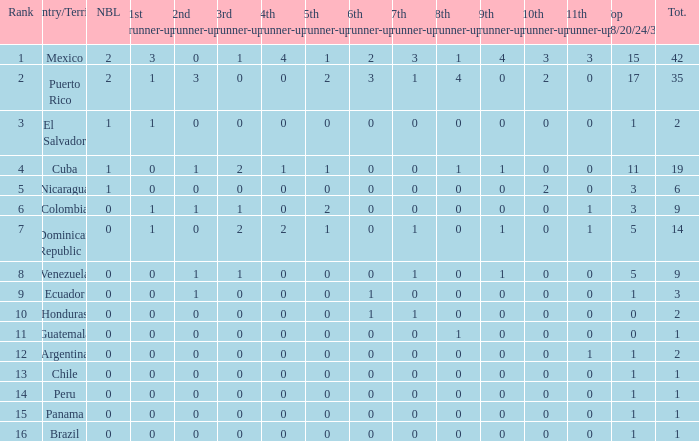What is the 3rd runner-up of the country with more than 0 9th runner-up, an 11th runner-up of 0, and the 1st runner-up greater than 0? None. Write the full table. {'header': ['Rank', 'Country/Territory', 'NBL', '1st runner-up', '2nd runner-up', '3rd runner-up', '4th runner-up', '5th runner-up', '6th runner-up', '7th runner-up', '8th runner-up', '9th runner-up', '10th runner-up', '11th runner-up', 'Top 18/20/24/30', 'Tot.'], 'rows': [['1', 'Mexico', '2', '3', '0', '1', '4', '1', '2', '3', '1', '4', '3', '3', '15', '42'], ['2', 'Puerto Rico', '2', '1', '3', '0', '0', '2', '3', '1', '4', '0', '2', '0', '17', '35'], ['3', 'El Salvador', '1', '1', '0', '0', '0', '0', '0', '0', '0', '0', '0', '0', '1', '2'], ['4', 'Cuba', '1', '0', '1', '2', '1', '1', '0', '0', '1', '1', '0', '0', '11', '19'], ['5', 'Nicaragua', '1', '0', '0', '0', '0', '0', '0', '0', '0', '0', '2', '0', '3', '6'], ['6', 'Colombia', '0', '1', '1', '1', '0', '2', '0', '0', '0', '0', '0', '1', '3', '9'], ['7', 'Dominican Republic', '0', '1', '0', '2', '2', '1', '0', '1', '0', '1', '0', '1', '5', '14'], ['8', 'Venezuela', '0', '0', '1', '1', '0', '0', '0', '1', '0', '1', '0', '0', '5', '9'], ['9', 'Ecuador', '0', '0', '1', '0', '0', '0', '1', '0', '0', '0', '0', '0', '1', '3'], ['10', 'Honduras', '0', '0', '0', '0', '0', '0', '1', '1', '0', '0', '0', '0', '0', '2'], ['11', 'Guatemala', '0', '0', '0', '0', '0', '0', '0', '0', '1', '0', '0', '0', '0', '1'], ['12', 'Argentina', '0', '0', '0', '0', '0', '0', '0', '0', '0', '0', '0', '1', '1', '2'], ['13', 'Chile', '0', '0', '0', '0', '0', '0', '0', '0', '0', '0', '0', '0', '1', '1'], ['14', 'Peru', '0', '0', '0', '0', '0', '0', '0', '0', '0', '0', '0', '0', '1', '1'], ['15', 'Panama', '0', '0', '0', '0', '0', '0', '0', '0', '0', '0', '0', '0', '1', '1'], ['16', 'Brazil', '0', '0', '0', '0', '0', '0', '0', '0', '0', '0', '0', '0', '1', '1']]} 